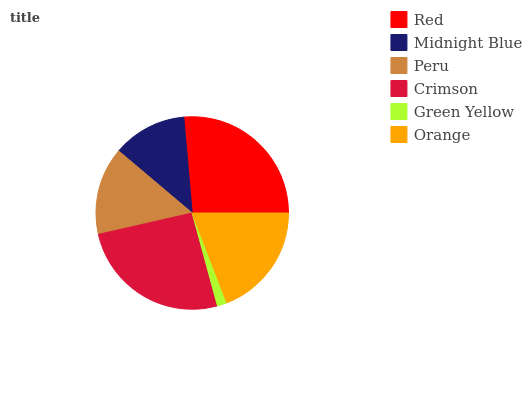Is Green Yellow the minimum?
Answer yes or no. Yes. Is Red the maximum?
Answer yes or no. Yes. Is Midnight Blue the minimum?
Answer yes or no. No. Is Midnight Blue the maximum?
Answer yes or no. No. Is Red greater than Midnight Blue?
Answer yes or no. Yes. Is Midnight Blue less than Red?
Answer yes or no. Yes. Is Midnight Blue greater than Red?
Answer yes or no. No. Is Red less than Midnight Blue?
Answer yes or no. No. Is Orange the high median?
Answer yes or no. Yes. Is Peru the low median?
Answer yes or no. Yes. Is Peru the high median?
Answer yes or no. No. Is Crimson the low median?
Answer yes or no. No. 